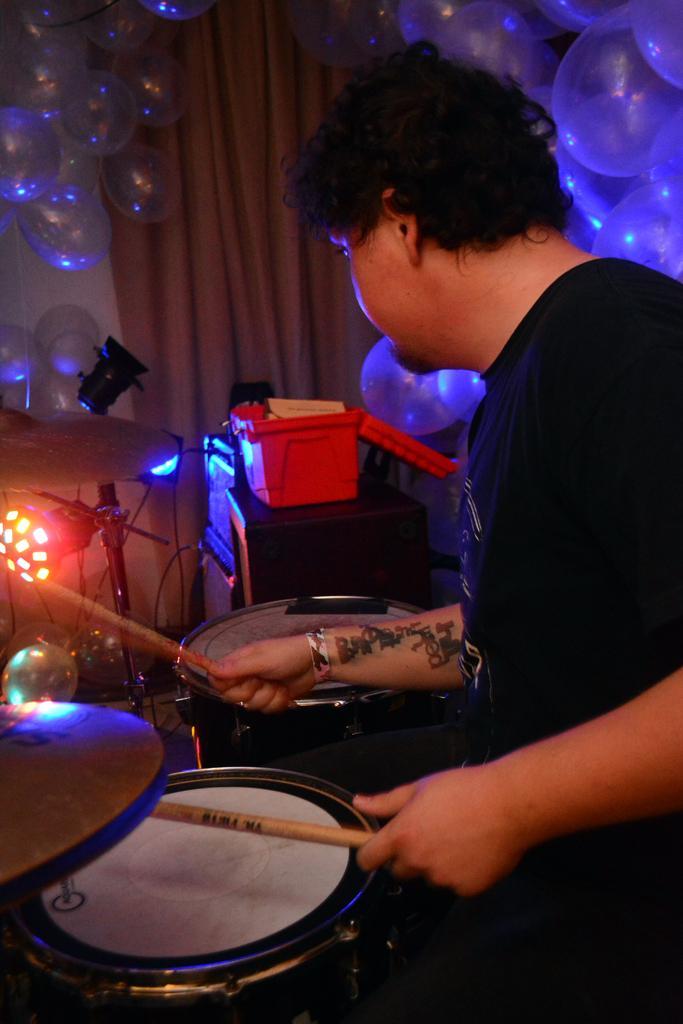Describe this image in one or two sentences. In this image we can see a person playing musical instrument and we can see some balloons and some other objects and there is a curtain in the background. 